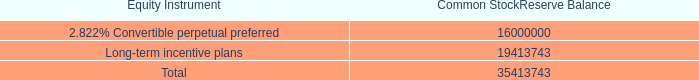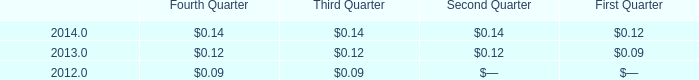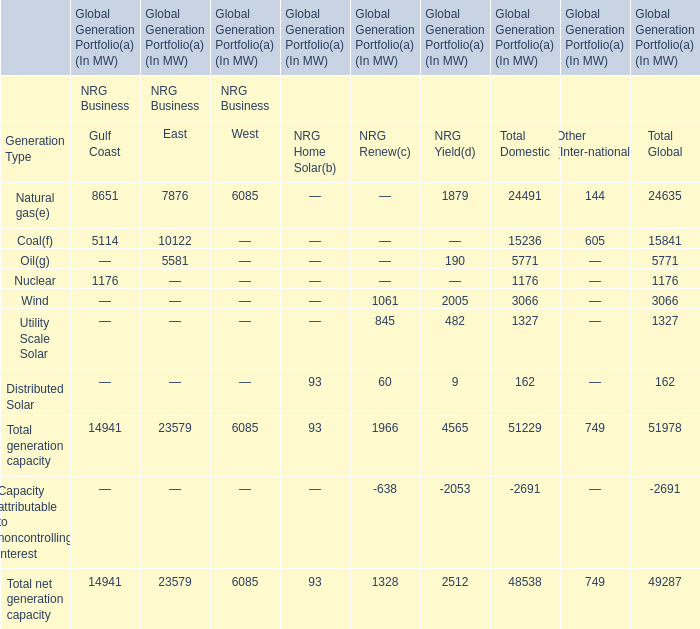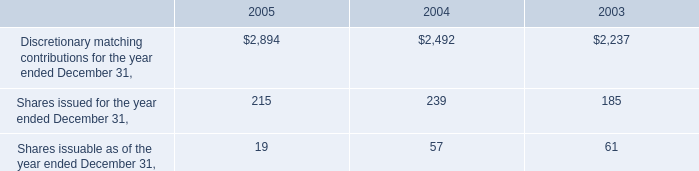Does the proportion of Natural gas in total larger than that of Coal for Gulf Coast ? 
Answer: yes. 